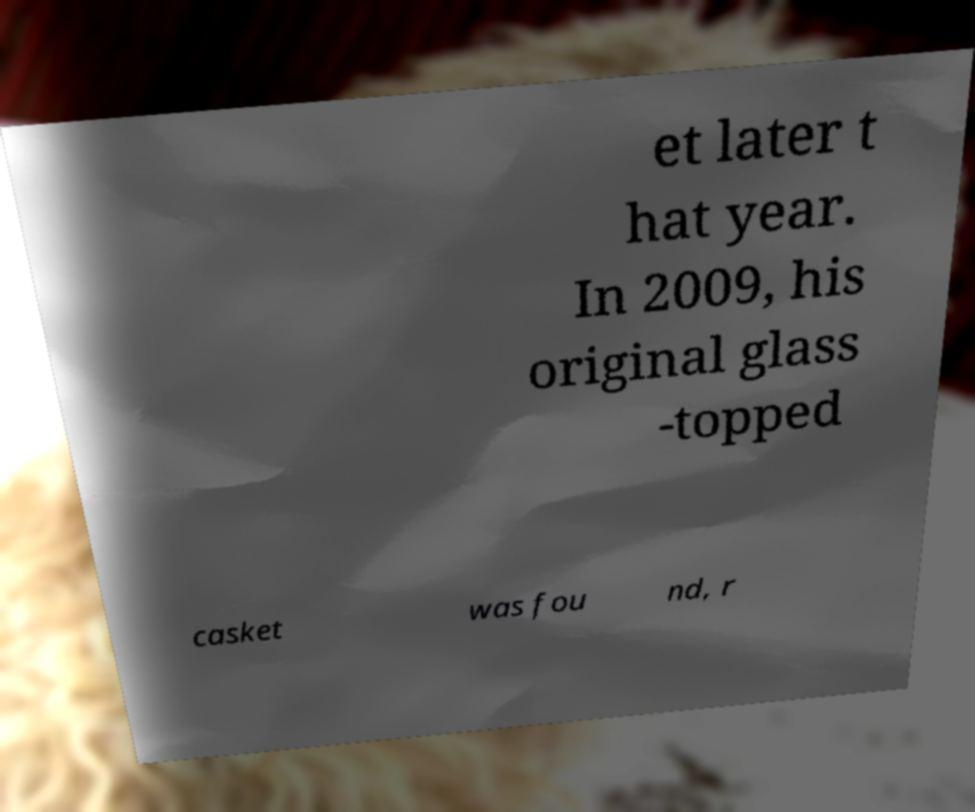For documentation purposes, I need the text within this image transcribed. Could you provide that? et later t hat year. In 2009, his original glass -topped casket was fou nd, r 